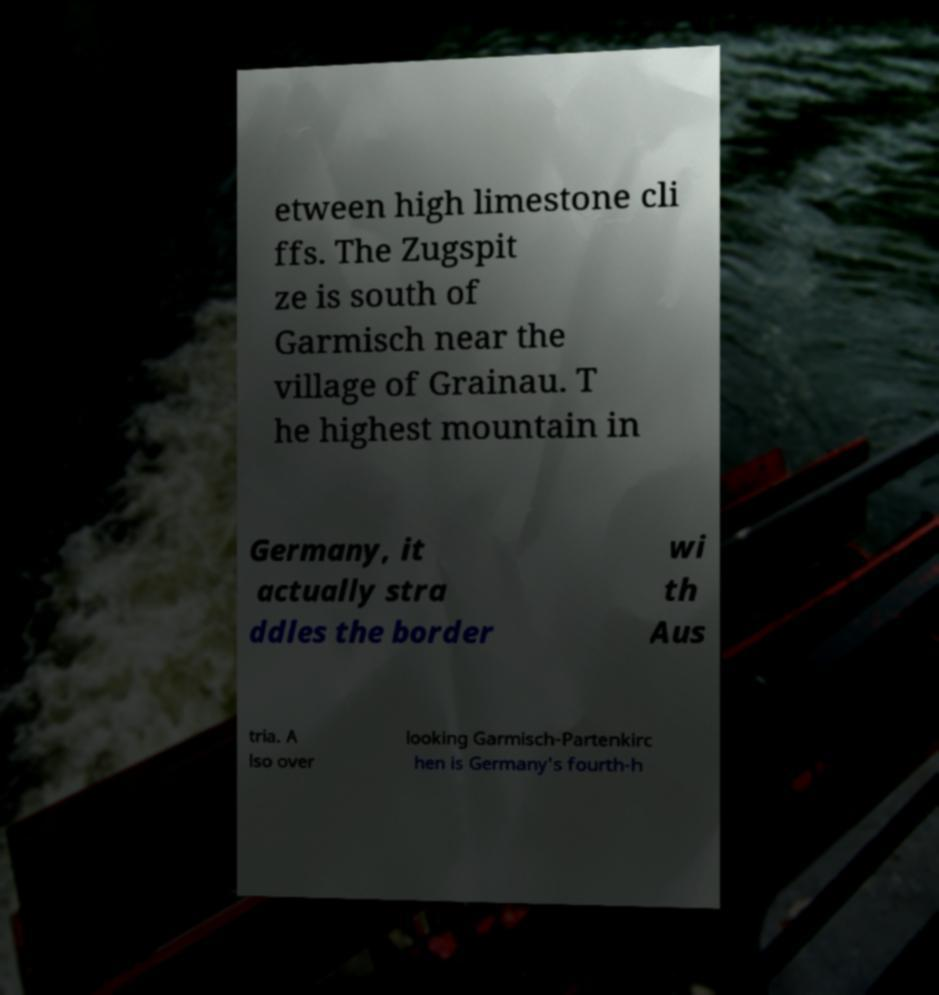Can you accurately transcribe the text from the provided image for me? etween high limestone cli ffs. The Zugspit ze is south of Garmisch near the village of Grainau. T he highest mountain in Germany, it actually stra ddles the border wi th Aus tria. A lso over looking Garmisch-Partenkirc hen is Germany's fourth-h 